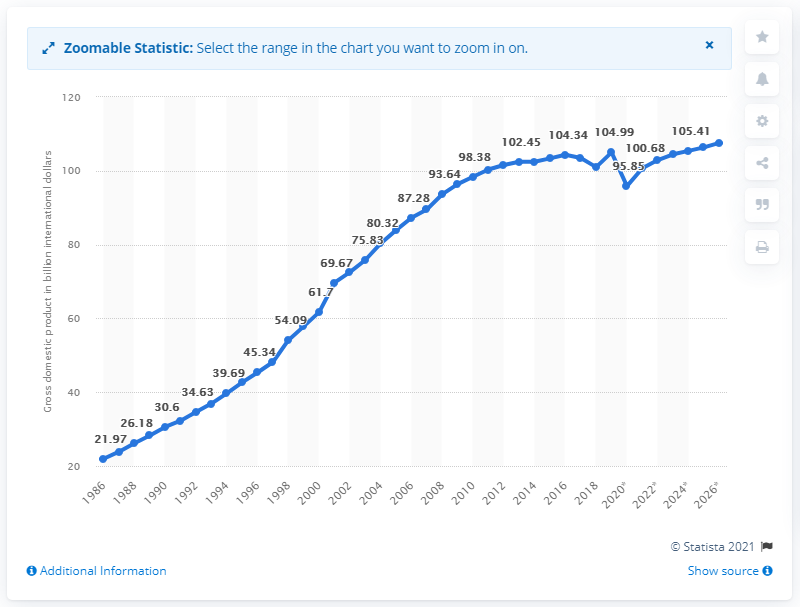Specify some key components in this picture. In 2019, the gross domestic product (GDP) of Puerto Rico was 105.41 billion dollars. 